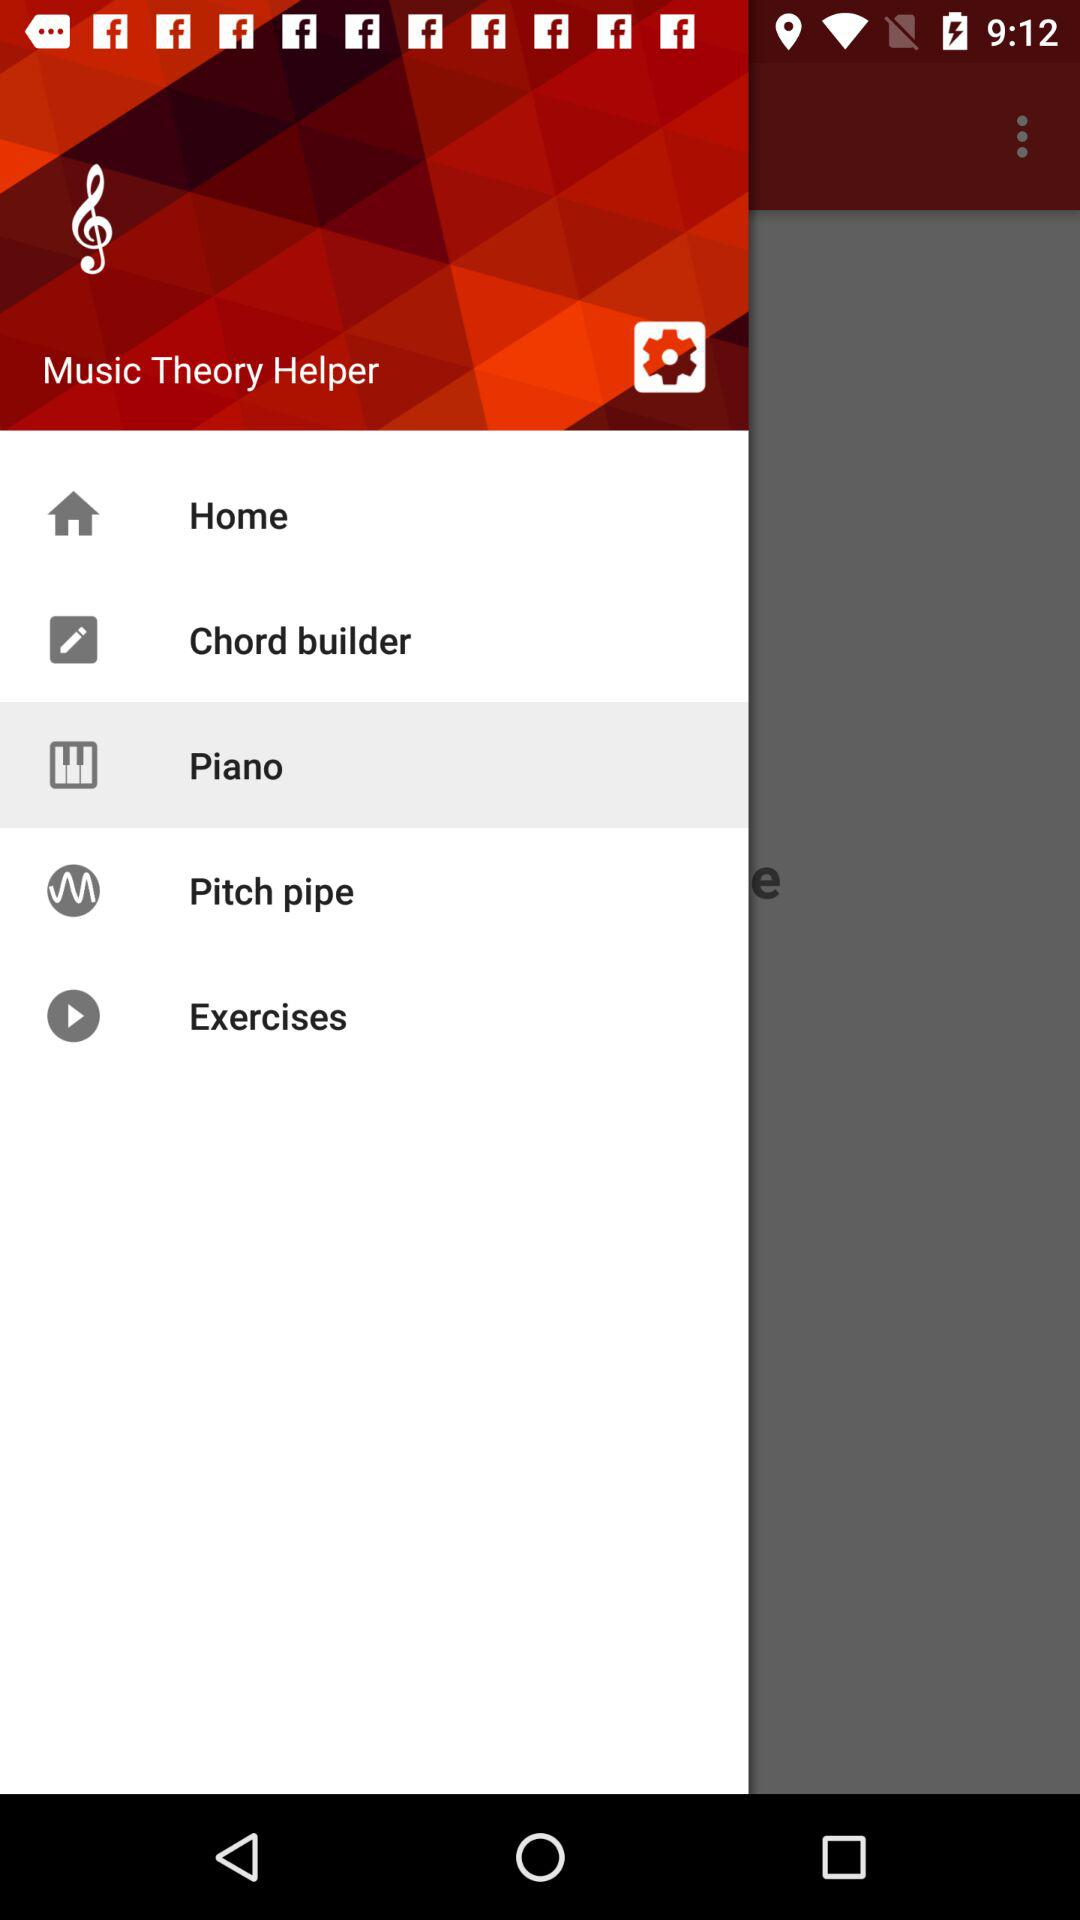What is the application name? The application name is "Music Theory Helper". 